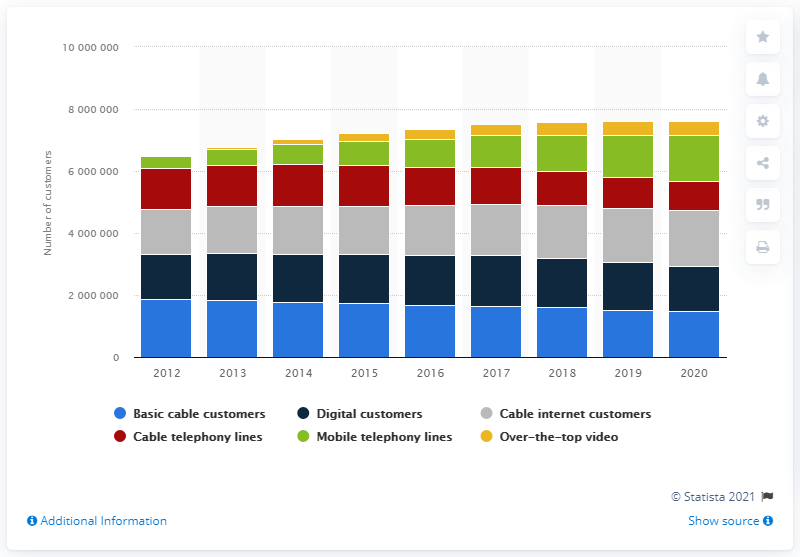Identify some key points in this picture. In 2020, Videotron had 469,700 customers who subscribed to their over-the-top video services. In 2013, the number of OTT subscribers began to increase. In 2020, Videotron had a total of 147,5600 basic cable customers. 